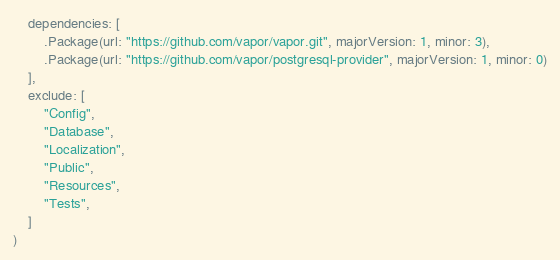Convert code to text. <code><loc_0><loc_0><loc_500><loc_500><_Swift_>    dependencies: [
        .Package(url: "https://github.com/vapor/vapor.git", majorVersion: 1, minor: 3),
        .Package(url: "https://github.com/vapor/postgresql-provider", majorVersion: 1, minor: 0)
    ],
    exclude: [
        "Config",
        "Database",
        "Localization",
        "Public",
        "Resources",
        "Tests",
    ]
)

</code> 